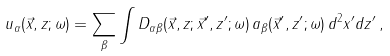Convert formula to latex. <formula><loc_0><loc_0><loc_500><loc_500>u _ { \alpha } ( \vec { x } , z ; \omega ) = \sum _ { \beta } \int D _ { \alpha \beta } ( \vec { x } , z ; \vec { x } ^ { \prime } , z ^ { \prime } ; \omega ) \, a _ { \beta } ( \vec { x } ^ { \prime } , z ^ { \prime } ; \omega ) \, d ^ { 2 } x ^ { \prime } d z ^ { \prime } \, ,</formula> 